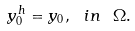<formula> <loc_0><loc_0><loc_500><loc_500>y _ { 0 } ^ { h } = y _ { 0 } , \ i n \ \Omega .</formula> 